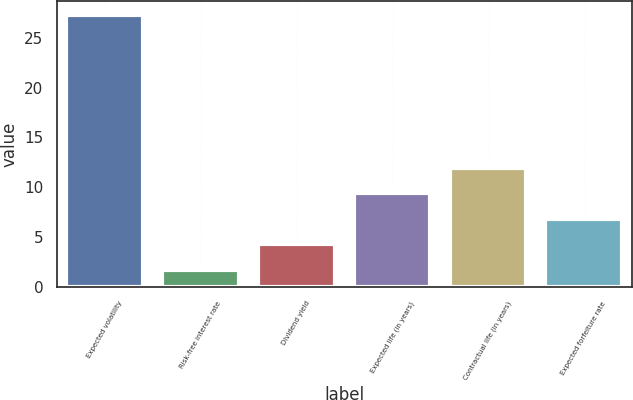<chart> <loc_0><loc_0><loc_500><loc_500><bar_chart><fcel>Expected volatility<fcel>Risk-free interest rate<fcel>Dividend yield<fcel>Expected life (in years)<fcel>Contractual life (in years)<fcel>Expected forfeiture rate<nl><fcel>27.3<fcel>1.7<fcel>4.26<fcel>9.38<fcel>11.94<fcel>6.82<nl></chart> 